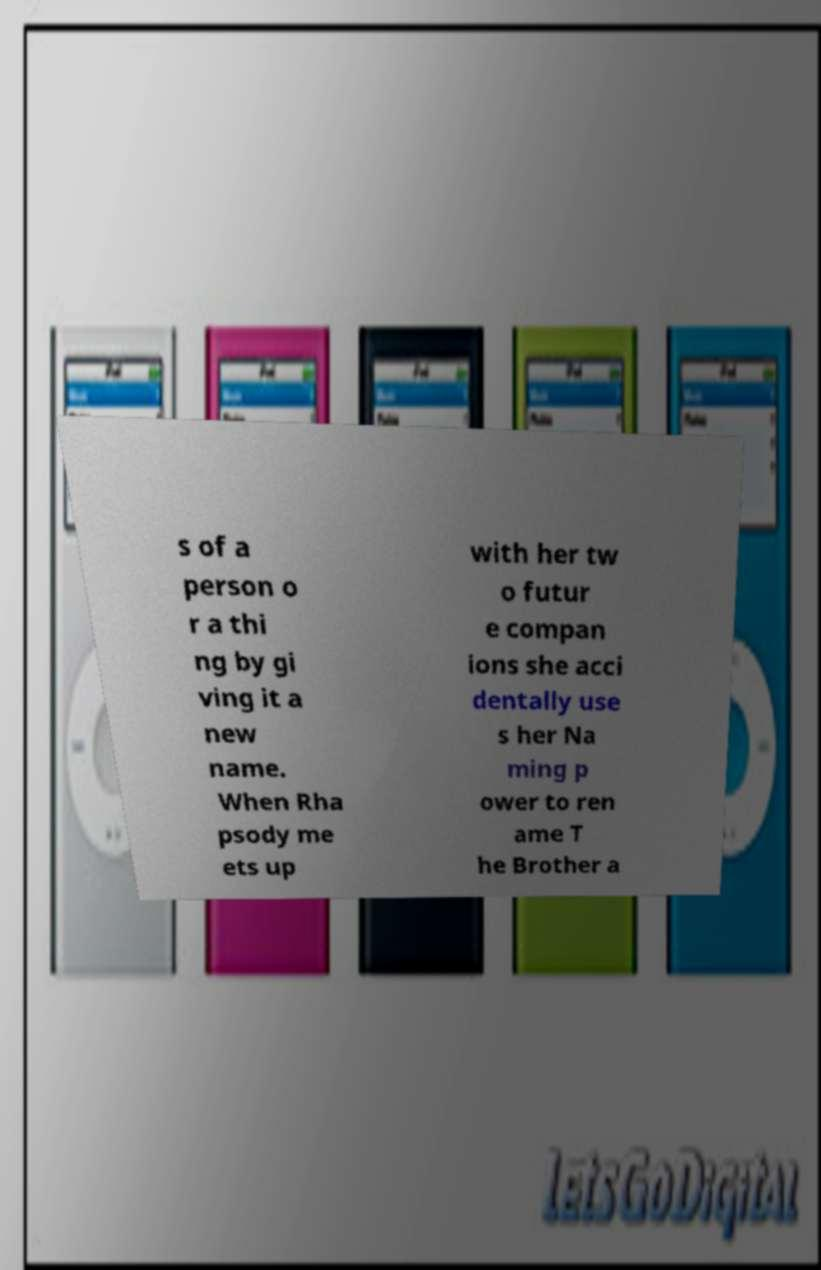Please read and relay the text visible in this image. What does it say? s of a person o r a thi ng by gi ving it a new name. When Rha psody me ets up with her tw o futur e compan ions she acci dentally use s her Na ming p ower to ren ame T he Brother a 